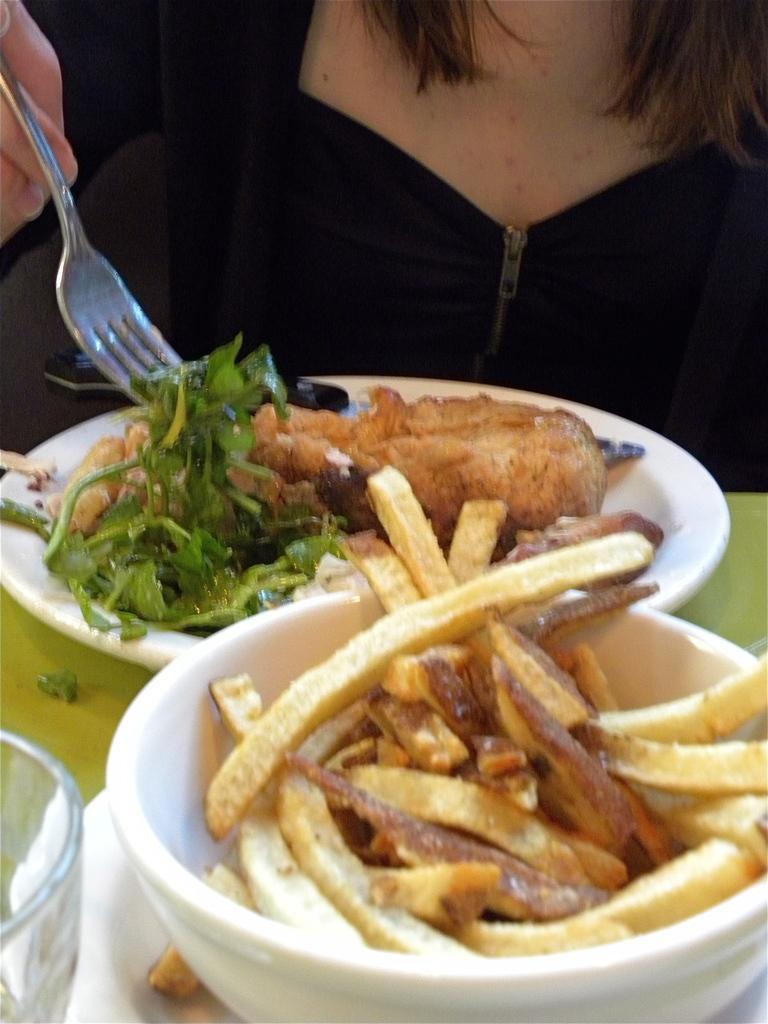Describe this image in one or two sentences. In this image we can see a woman holding a fork. We can also see some food in a plate, glass and french fries in a bowl which are placed on a table. 